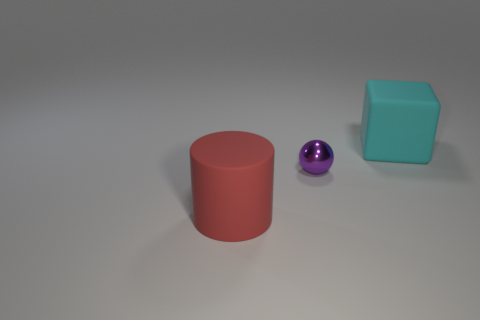Subtract 1 spheres. How many spheres are left? 0 Add 1 tiny brown spheres. How many objects exist? 4 Subtract all cylinders. How many objects are left? 2 Subtract all big cyan metallic things. Subtract all matte things. How many objects are left? 1 Add 3 cyan objects. How many cyan objects are left? 4 Add 1 large yellow blocks. How many large yellow blocks exist? 1 Subtract 0 purple blocks. How many objects are left? 3 Subtract all green cylinders. Subtract all green spheres. How many cylinders are left? 1 Subtract all cyan cubes. How many brown balls are left? 0 